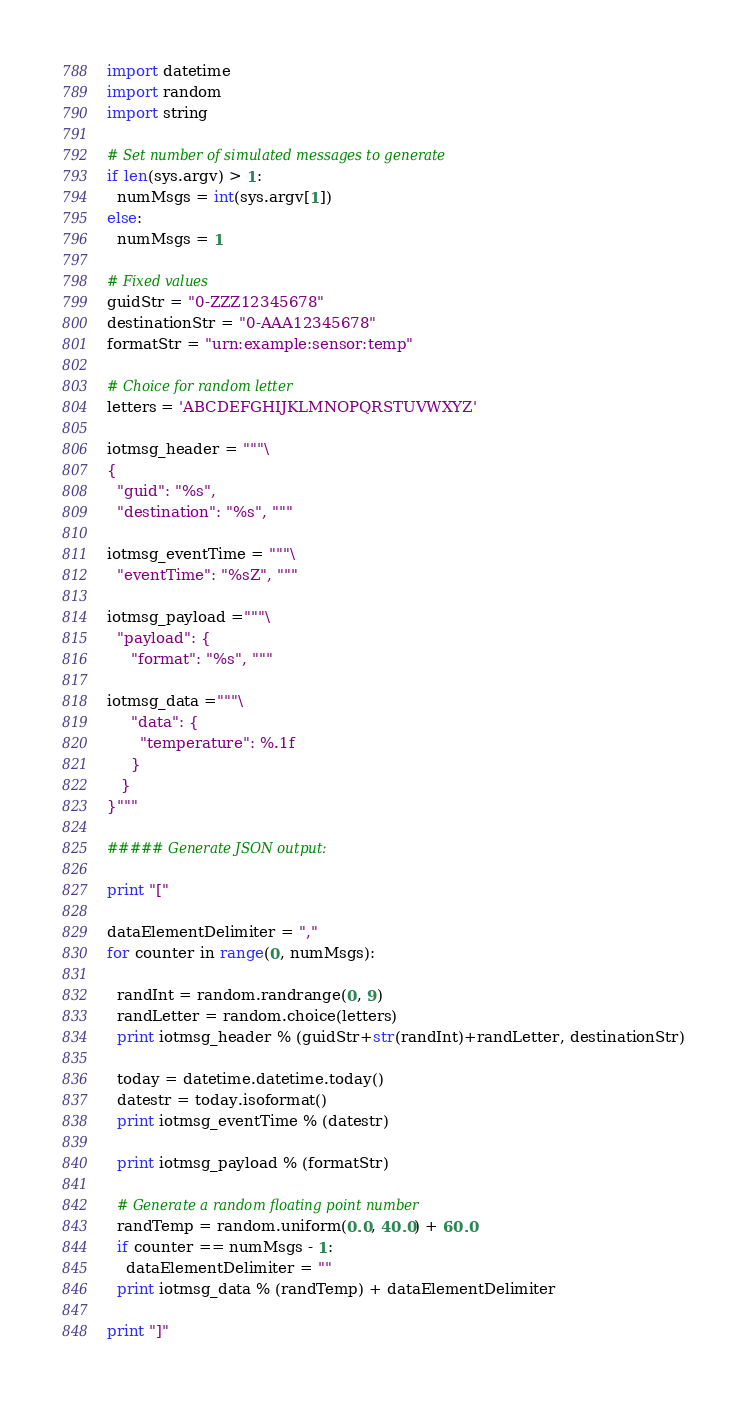<code> <loc_0><loc_0><loc_500><loc_500><_Python_>import datetime
import random
import string

# Set number of simulated messages to generate
if len(sys.argv) > 1:
  numMsgs = int(sys.argv[1])
else:
  numMsgs = 1

# Fixed values
guidStr = "0-ZZZ12345678"
destinationStr = "0-AAA12345678"
formatStr = "urn:example:sensor:temp"

# Choice for random letter
letters = 'ABCDEFGHIJKLMNOPQRSTUVWXYZ'

iotmsg_header = """\
{
  "guid": "%s",
  "destination": "%s", """

iotmsg_eventTime = """\
  "eventTime": "%sZ", """

iotmsg_payload ="""\
  "payload": {
     "format": "%s", """

iotmsg_data ="""\
     "data": {
       "temperature": %.1f
     }
   }
}"""

##### Generate JSON output:

print "["

dataElementDelimiter = ","
for counter in range(0, numMsgs):

  randInt = random.randrange(0, 9)
  randLetter = random.choice(letters)
  print iotmsg_header % (guidStr+str(randInt)+randLetter, destinationStr)

  today = datetime.datetime.today()
  datestr = today.isoformat()
  print iotmsg_eventTime % (datestr)

  print iotmsg_payload % (formatStr)

  # Generate a random floating point number
  randTemp = random.uniform(0.0, 40.0) + 60.0
  if counter == numMsgs - 1:
    dataElementDelimiter = ""
  print iotmsg_data % (randTemp) + dataElementDelimiter

print "]"</code> 